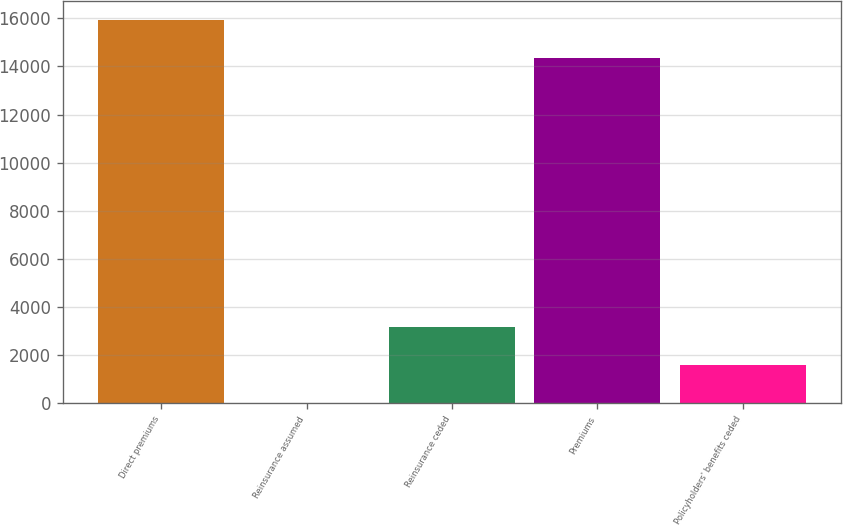Convert chart. <chart><loc_0><loc_0><loc_500><loc_500><bar_chart><fcel>Direct premiums<fcel>Reinsurance assumed<fcel>Reinsurance ceded<fcel>Premiums<fcel>Policyholders' benefits ceded<nl><fcel>15916.3<fcel>35<fcel>3165.6<fcel>14351<fcel>1600.3<nl></chart> 